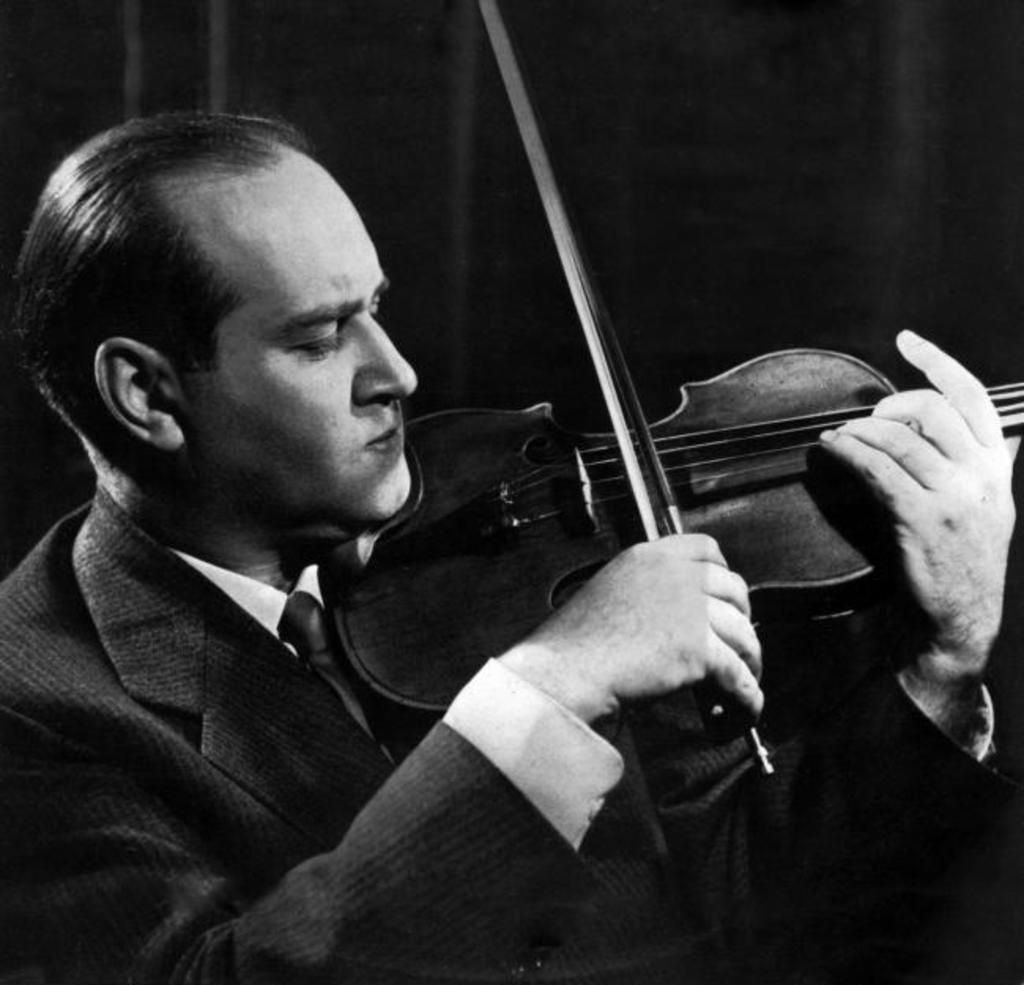What is the main subject of the image? There is a man in the image. What is the man doing in the image? The man is playing a musical instrument. How is the man holding the musical instrument? The man is holding the musical instrument in his hand. What type of shade can be seen in the wilderness behind the man? There is no shade or wilderness present in the image; it only features a man playing a musical instrument. 